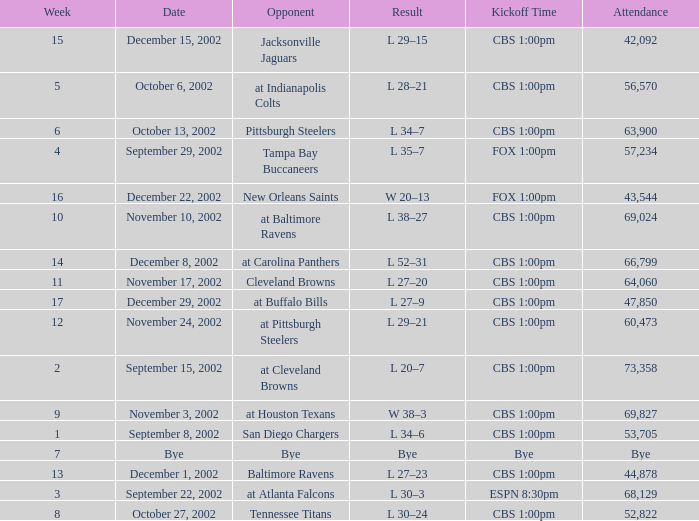What week number was the kickoff time cbs 1:00pm, with 60,473 people in attendance? 1.0. I'm looking to parse the entire table for insights. Could you assist me with that? {'header': ['Week', 'Date', 'Opponent', 'Result', 'Kickoff Time', 'Attendance'], 'rows': [['15', 'December 15, 2002', 'Jacksonville Jaguars', 'L 29–15', 'CBS 1:00pm', '42,092'], ['5', 'October 6, 2002', 'at Indianapolis Colts', 'L 28–21', 'CBS 1:00pm', '56,570'], ['6', 'October 13, 2002', 'Pittsburgh Steelers', 'L 34–7', 'CBS 1:00pm', '63,900'], ['4', 'September 29, 2002', 'Tampa Bay Buccaneers', 'L 35–7', 'FOX 1:00pm', '57,234'], ['16', 'December 22, 2002', 'New Orleans Saints', 'W 20–13', 'FOX 1:00pm', '43,544'], ['10', 'November 10, 2002', 'at Baltimore Ravens', 'L 38–27', 'CBS 1:00pm', '69,024'], ['14', 'December 8, 2002', 'at Carolina Panthers', 'L 52–31', 'CBS 1:00pm', '66,799'], ['11', 'November 17, 2002', 'Cleveland Browns', 'L 27–20', 'CBS 1:00pm', '64,060'], ['17', 'December 29, 2002', 'at Buffalo Bills', 'L 27–9', 'CBS 1:00pm', '47,850'], ['12', 'November 24, 2002', 'at Pittsburgh Steelers', 'L 29–21', 'CBS 1:00pm', '60,473'], ['2', 'September 15, 2002', 'at Cleveland Browns', 'L 20–7', 'CBS 1:00pm', '73,358'], ['9', 'November 3, 2002', 'at Houston Texans', 'W 38–3', 'CBS 1:00pm', '69,827'], ['1', 'September 8, 2002', 'San Diego Chargers', 'L 34–6', 'CBS 1:00pm', '53,705'], ['7', 'Bye', 'Bye', 'Bye', 'Bye', 'Bye'], ['13', 'December 1, 2002', 'Baltimore Ravens', 'L 27–23', 'CBS 1:00pm', '44,878'], ['3', 'September 22, 2002', 'at Atlanta Falcons', 'L 30–3', 'ESPN 8:30pm', '68,129'], ['8', 'October 27, 2002', 'Tennessee Titans', 'L 30–24', 'CBS 1:00pm', '52,822']]} 